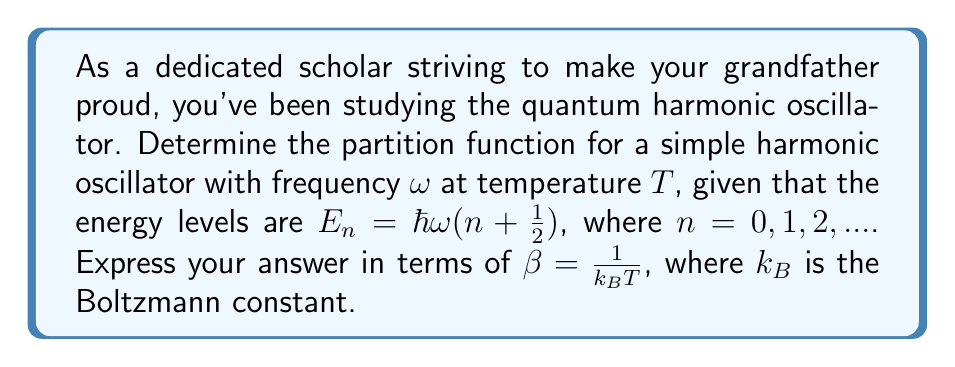What is the answer to this math problem? Let's approach this step-by-step:

1) The partition function $Z$ is defined as the sum over all possible states:

   $$Z = \sum_{n=0}^{\infty} e^{-\beta E_n}$$

2) Substitute the energy levels $E_n = \hbar\omega(n + \frac{1}{2})$:

   $$Z = \sum_{n=0}^{\infty} e^{-\beta \hbar\omega(n + \frac{1}{2})}$$

3) Factor out the constant term:

   $$Z = e^{-\beta \hbar\omega/2} \sum_{n=0}^{\infty} e^{-\beta \hbar\omega n}$$

4) Let $x = e^{-\beta \hbar\omega}$. Then the sum becomes a geometric series:

   $$Z = e^{-\beta \hbar\omega/2} \sum_{n=0}^{\infty} x^n$$

5) The sum of a geometric series with $|x| < 1$ is given by $\frac{1}{1-x}$:

   $$Z = e^{-\beta \hbar\omega/2} \frac{1}{1-e^{-\beta \hbar\omega}}$$

6) This can be rewritten as:

   $$Z = \frac{e^{-\beta \hbar\omega/2}}{1-e^{-\beta \hbar\omega}}$$

This is the partition function for a simple harmonic oscillator.
Answer: $$Z = \frac{e^{-\beta \hbar\omega/2}}{1-e^{-\beta \hbar\omega}}$$ 